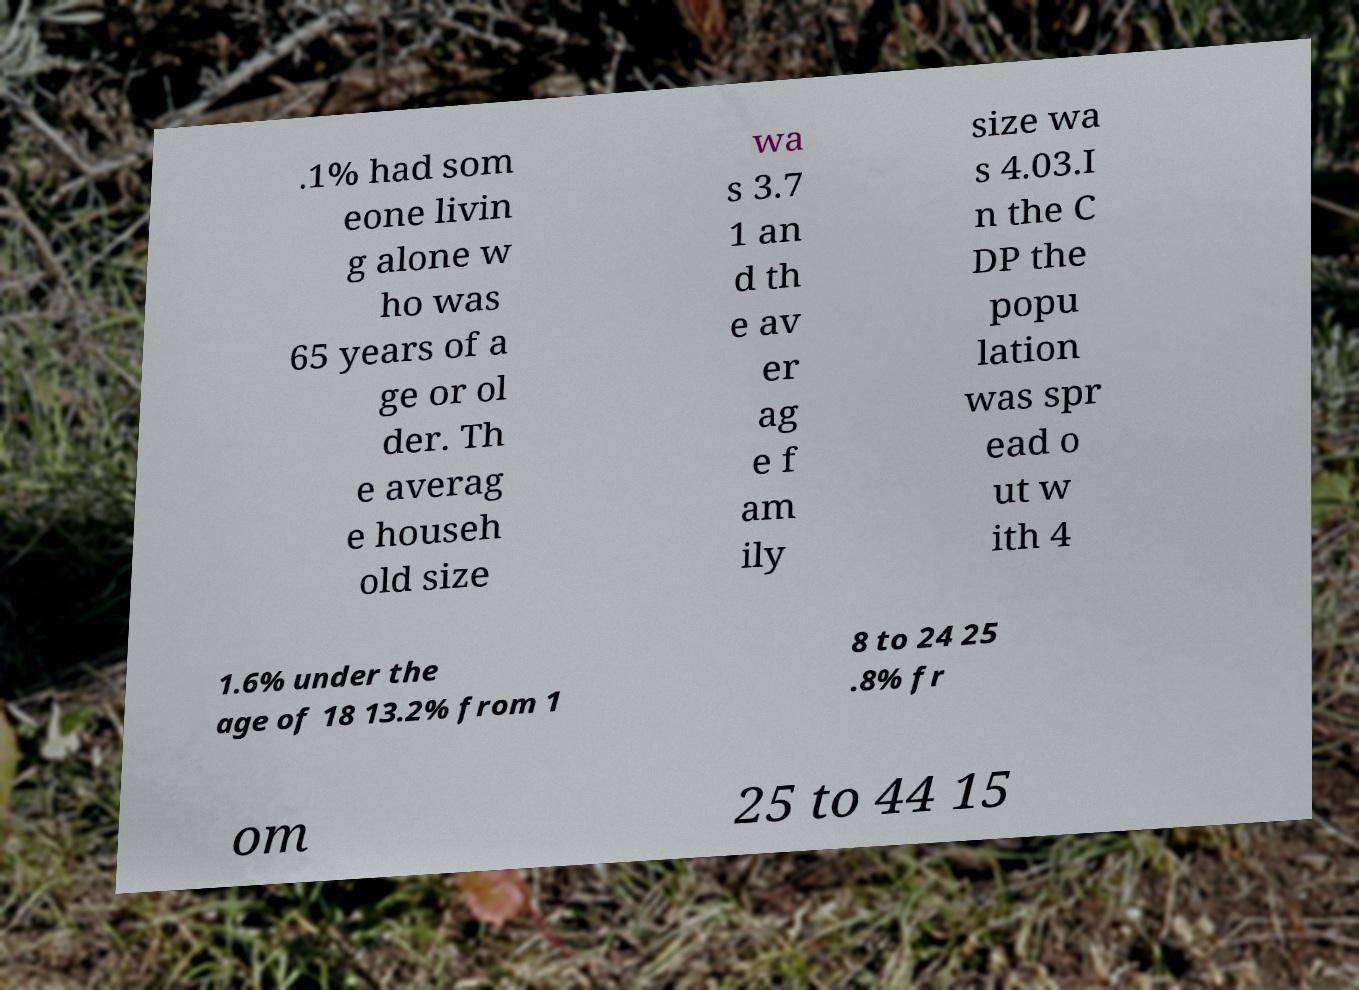Please read and relay the text visible in this image. What does it say? .1% had som eone livin g alone w ho was 65 years of a ge or ol der. Th e averag e househ old size wa s 3.7 1 an d th e av er ag e f am ily size wa s 4.03.I n the C DP the popu lation was spr ead o ut w ith 4 1.6% under the age of 18 13.2% from 1 8 to 24 25 .8% fr om 25 to 44 15 